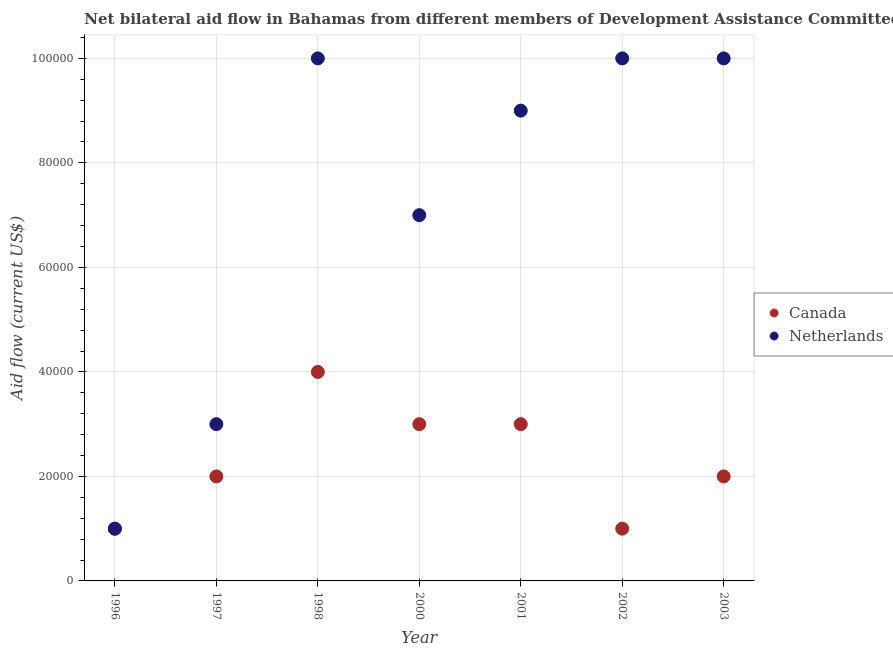How many different coloured dotlines are there?
Ensure brevity in your answer.  2. Is the number of dotlines equal to the number of legend labels?
Ensure brevity in your answer.  Yes. What is the amount of aid given by canada in 1997?
Give a very brief answer. 2.00e+04. Across all years, what is the maximum amount of aid given by netherlands?
Your answer should be very brief. 1.00e+05. Across all years, what is the minimum amount of aid given by canada?
Give a very brief answer. 10000. In which year was the amount of aid given by netherlands minimum?
Your answer should be very brief. 1996. What is the total amount of aid given by canada in the graph?
Give a very brief answer. 1.60e+05. What is the difference between the amount of aid given by canada in 1996 and that in 1997?
Offer a terse response. -10000. What is the difference between the amount of aid given by canada in 1997 and the amount of aid given by netherlands in 1996?
Provide a succinct answer. 10000. What is the average amount of aid given by canada per year?
Offer a very short reply. 2.29e+04. In how many years, is the amount of aid given by netherlands greater than 88000 US$?
Offer a very short reply. 4. What is the ratio of the amount of aid given by netherlands in 1997 to that in 2001?
Your response must be concise. 0.33. What is the difference between the highest and the second highest amount of aid given by netherlands?
Provide a short and direct response. 0. What is the difference between the highest and the lowest amount of aid given by canada?
Provide a succinct answer. 3.00e+04. Is the sum of the amount of aid given by netherlands in 1996 and 2000 greater than the maximum amount of aid given by canada across all years?
Provide a succinct answer. Yes. Does the amount of aid given by netherlands monotonically increase over the years?
Your answer should be very brief. No. Is the amount of aid given by netherlands strictly greater than the amount of aid given by canada over the years?
Ensure brevity in your answer.  No. What is the difference between two consecutive major ticks on the Y-axis?
Give a very brief answer. 2.00e+04. Does the graph contain grids?
Give a very brief answer. Yes. Where does the legend appear in the graph?
Keep it short and to the point. Center right. What is the title of the graph?
Offer a very short reply. Net bilateral aid flow in Bahamas from different members of Development Assistance Committee. What is the Aid flow (current US$) of Netherlands in 1996?
Your response must be concise. 10000. What is the Aid flow (current US$) of Canada in 1998?
Offer a terse response. 4.00e+04. What is the Aid flow (current US$) in Canada in 2000?
Offer a very short reply. 3.00e+04. What is the Aid flow (current US$) in Netherlands in 2001?
Provide a succinct answer. 9.00e+04. What is the Aid flow (current US$) in Canada in 2003?
Your response must be concise. 2.00e+04. What is the Aid flow (current US$) in Netherlands in 2003?
Offer a very short reply. 1.00e+05. Across all years, what is the maximum Aid flow (current US$) of Canada?
Your answer should be very brief. 4.00e+04. Across all years, what is the maximum Aid flow (current US$) of Netherlands?
Provide a succinct answer. 1.00e+05. What is the total Aid flow (current US$) of Canada in the graph?
Your answer should be very brief. 1.60e+05. What is the total Aid flow (current US$) of Netherlands in the graph?
Keep it short and to the point. 5.00e+05. What is the difference between the Aid flow (current US$) of Netherlands in 1996 and that in 1997?
Make the answer very short. -2.00e+04. What is the difference between the Aid flow (current US$) in Netherlands in 1996 and that in 1998?
Your answer should be very brief. -9.00e+04. What is the difference between the Aid flow (current US$) of Canada in 1996 and that in 2000?
Provide a succinct answer. -2.00e+04. What is the difference between the Aid flow (current US$) of Canada in 1996 and that in 2001?
Make the answer very short. -2.00e+04. What is the difference between the Aid flow (current US$) of Canada in 1996 and that in 2002?
Keep it short and to the point. 0. What is the difference between the Aid flow (current US$) of Canada in 1996 and that in 2003?
Your answer should be compact. -10000. What is the difference between the Aid flow (current US$) in Netherlands in 1996 and that in 2003?
Your answer should be very brief. -9.00e+04. What is the difference between the Aid flow (current US$) of Canada in 1997 and that in 2000?
Offer a terse response. -10000. What is the difference between the Aid flow (current US$) of Canada in 1997 and that in 2001?
Make the answer very short. -10000. What is the difference between the Aid flow (current US$) in Canada in 1997 and that in 2002?
Give a very brief answer. 10000. What is the difference between the Aid flow (current US$) in Netherlands in 1997 and that in 2002?
Keep it short and to the point. -7.00e+04. What is the difference between the Aid flow (current US$) of Netherlands in 1997 and that in 2003?
Your answer should be compact. -7.00e+04. What is the difference between the Aid flow (current US$) in Canada in 1998 and that in 2000?
Provide a short and direct response. 10000. What is the difference between the Aid flow (current US$) of Netherlands in 1998 and that in 2000?
Offer a very short reply. 3.00e+04. What is the difference between the Aid flow (current US$) of Canada in 1998 and that in 2001?
Provide a short and direct response. 10000. What is the difference between the Aid flow (current US$) of Netherlands in 1998 and that in 2001?
Give a very brief answer. 10000. What is the difference between the Aid flow (current US$) of Canada in 1998 and that in 2002?
Your response must be concise. 3.00e+04. What is the difference between the Aid flow (current US$) of Netherlands in 1998 and that in 2002?
Give a very brief answer. 0. What is the difference between the Aid flow (current US$) in Netherlands in 2000 and that in 2001?
Keep it short and to the point. -2.00e+04. What is the difference between the Aid flow (current US$) of Canada in 2000 and that in 2003?
Your answer should be compact. 10000. What is the difference between the Aid flow (current US$) in Netherlands in 2001 and that in 2002?
Offer a terse response. -10000. What is the difference between the Aid flow (current US$) in Canada in 2001 and that in 2003?
Give a very brief answer. 10000. What is the difference between the Aid flow (current US$) in Canada in 1996 and the Aid flow (current US$) in Netherlands in 1997?
Give a very brief answer. -2.00e+04. What is the difference between the Aid flow (current US$) in Canada in 1996 and the Aid flow (current US$) in Netherlands in 1998?
Ensure brevity in your answer.  -9.00e+04. What is the difference between the Aid flow (current US$) of Canada in 1997 and the Aid flow (current US$) of Netherlands in 1998?
Your answer should be compact. -8.00e+04. What is the difference between the Aid flow (current US$) in Canada in 1997 and the Aid flow (current US$) in Netherlands in 2000?
Offer a terse response. -5.00e+04. What is the difference between the Aid flow (current US$) in Canada in 1997 and the Aid flow (current US$) in Netherlands in 2001?
Offer a terse response. -7.00e+04. What is the difference between the Aid flow (current US$) in Canada in 1997 and the Aid flow (current US$) in Netherlands in 2002?
Your response must be concise. -8.00e+04. What is the difference between the Aid flow (current US$) in Canada in 1997 and the Aid flow (current US$) in Netherlands in 2003?
Your answer should be compact. -8.00e+04. What is the difference between the Aid flow (current US$) of Canada in 1998 and the Aid flow (current US$) of Netherlands in 2003?
Give a very brief answer. -6.00e+04. What is the difference between the Aid flow (current US$) in Canada in 2000 and the Aid flow (current US$) in Netherlands in 2001?
Your answer should be compact. -6.00e+04. What is the difference between the Aid flow (current US$) in Canada in 2001 and the Aid flow (current US$) in Netherlands in 2002?
Your response must be concise. -7.00e+04. What is the difference between the Aid flow (current US$) in Canada in 2001 and the Aid flow (current US$) in Netherlands in 2003?
Make the answer very short. -7.00e+04. What is the difference between the Aid flow (current US$) in Canada in 2002 and the Aid flow (current US$) in Netherlands in 2003?
Provide a succinct answer. -9.00e+04. What is the average Aid flow (current US$) in Canada per year?
Provide a succinct answer. 2.29e+04. What is the average Aid flow (current US$) of Netherlands per year?
Make the answer very short. 7.14e+04. In the year 1996, what is the difference between the Aid flow (current US$) in Canada and Aid flow (current US$) in Netherlands?
Give a very brief answer. 0. In the year 1997, what is the difference between the Aid flow (current US$) in Canada and Aid flow (current US$) in Netherlands?
Your answer should be compact. -10000. In the year 1998, what is the difference between the Aid flow (current US$) in Canada and Aid flow (current US$) in Netherlands?
Offer a very short reply. -6.00e+04. In the year 2001, what is the difference between the Aid flow (current US$) in Canada and Aid flow (current US$) in Netherlands?
Offer a very short reply. -6.00e+04. In the year 2003, what is the difference between the Aid flow (current US$) of Canada and Aid flow (current US$) of Netherlands?
Offer a terse response. -8.00e+04. What is the ratio of the Aid flow (current US$) in Netherlands in 1996 to that in 1997?
Offer a very short reply. 0.33. What is the ratio of the Aid flow (current US$) in Netherlands in 1996 to that in 1998?
Ensure brevity in your answer.  0.1. What is the ratio of the Aid flow (current US$) of Netherlands in 1996 to that in 2000?
Give a very brief answer. 0.14. What is the ratio of the Aid flow (current US$) in Netherlands in 1996 to that in 2001?
Provide a succinct answer. 0.11. What is the ratio of the Aid flow (current US$) in Canada in 1996 to that in 2002?
Provide a short and direct response. 1. What is the ratio of the Aid flow (current US$) of Netherlands in 1996 to that in 2003?
Offer a very short reply. 0.1. What is the ratio of the Aid flow (current US$) in Netherlands in 1997 to that in 2000?
Offer a very short reply. 0.43. What is the ratio of the Aid flow (current US$) in Netherlands in 1997 to that in 2001?
Your response must be concise. 0.33. What is the ratio of the Aid flow (current US$) of Canada in 1997 to that in 2003?
Ensure brevity in your answer.  1. What is the ratio of the Aid flow (current US$) in Netherlands in 1998 to that in 2000?
Keep it short and to the point. 1.43. What is the ratio of the Aid flow (current US$) of Canada in 1998 to that in 2002?
Your answer should be very brief. 4. What is the ratio of the Aid flow (current US$) of Netherlands in 1998 to that in 2002?
Keep it short and to the point. 1. What is the ratio of the Aid flow (current US$) of Canada in 1998 to that in 2003?
Provide a succinct answer. 2. What is the ratio of the Aid flow (current US$) in Netherlands in 1998 to that in 2003?
Offer a terse response. 1. What is the ratio of the Aid flow (current US$) in Canada in 2000 to that in 2001?
Provide a succinct answer. 1. What is the ratio of the Aid flow (current US$) of Netherlands in 2000 to that in 2001?
Keep it short and to the point. 0.78. What is the ratio of the Aid flow (current US$) in Canada in 2000 to that in 2002?
Ensure brevity in your answer.  3. What is the ratio of the Aid flow (current US$) in Netherlands in 2000 to that in 2002?
Offer a terse response. 0.7. What is the difference between the highest and the second highest Aid flow (current US$) of Canada?
Provide a short and direct response. 10000. What is the difference between the highest and the second highest Aid flow (current US$) of Netherlands?
Offer a terse response. 0. 